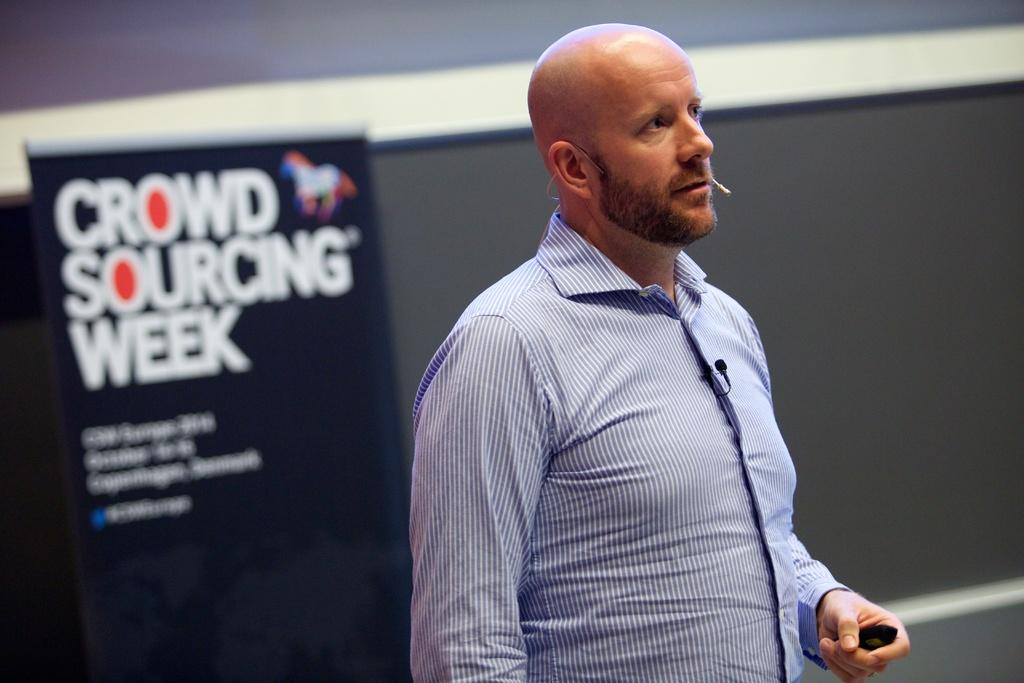What is the main subject of the image? There is a person standing in the image. What is the person holding in the image? The person is holding an object. What can be seen on the left side of the image? There is an advertising banner at the left side of the image. What is present in the background of the image? There is a wall in the image. What type of screw is being used to make a decision in the image? There is no screw or decision-making process depicted in the image. 